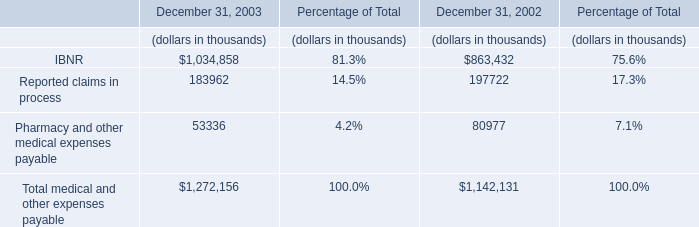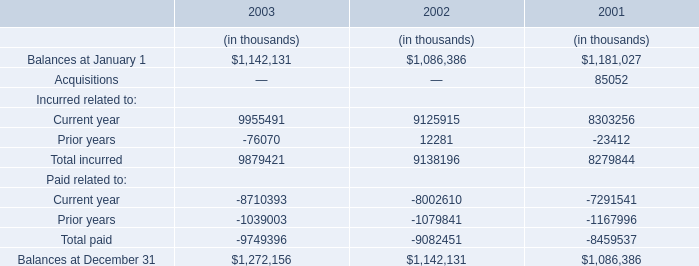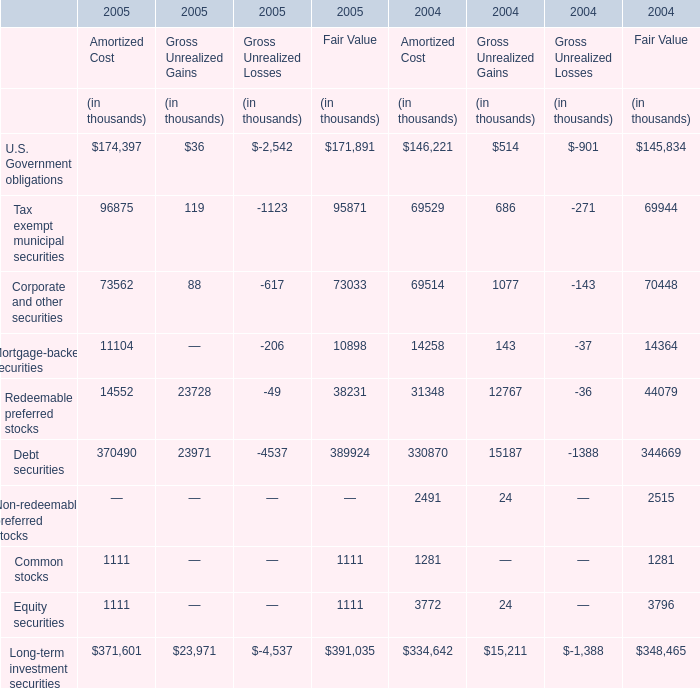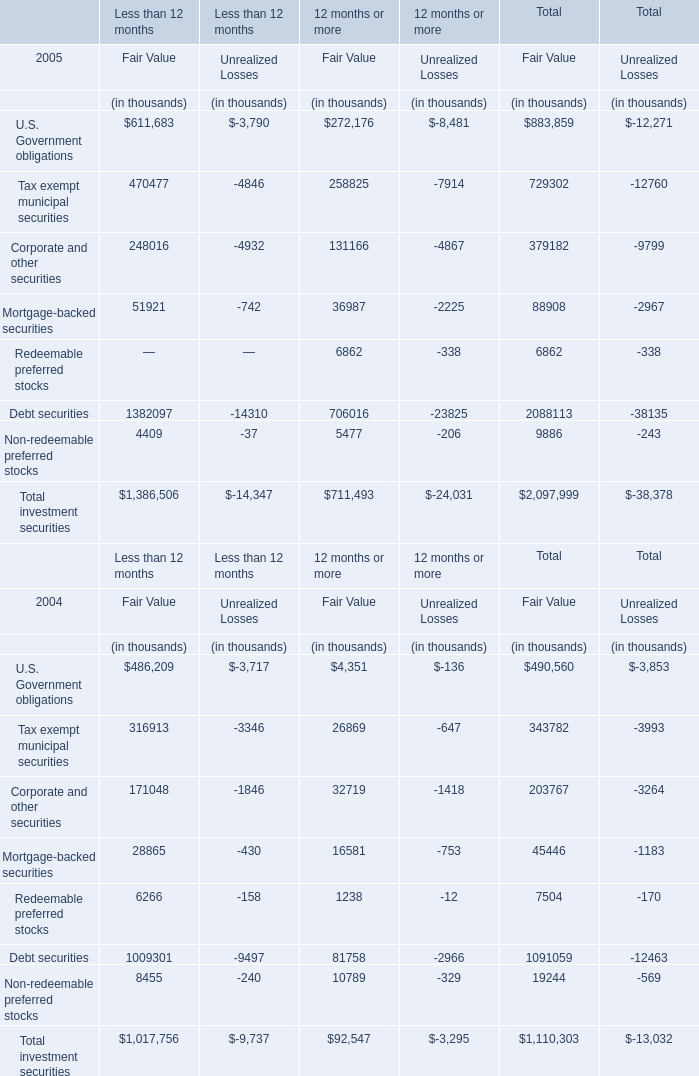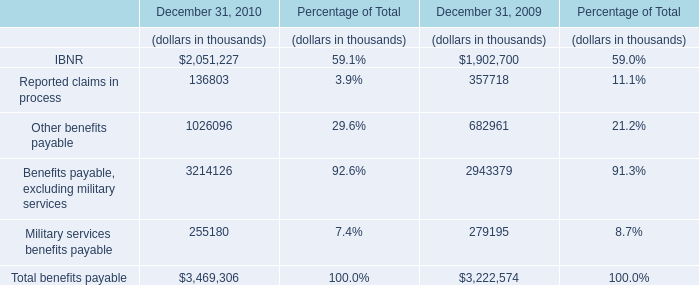In the year with lower Gross Unrealized Losses for Mortgage-backed securities, what's the growth rate of Gross Unrealized Gains for Corporate and other securities? 
Computations: ((88 - 1077) / 1077)
Answer: -0.91829. 